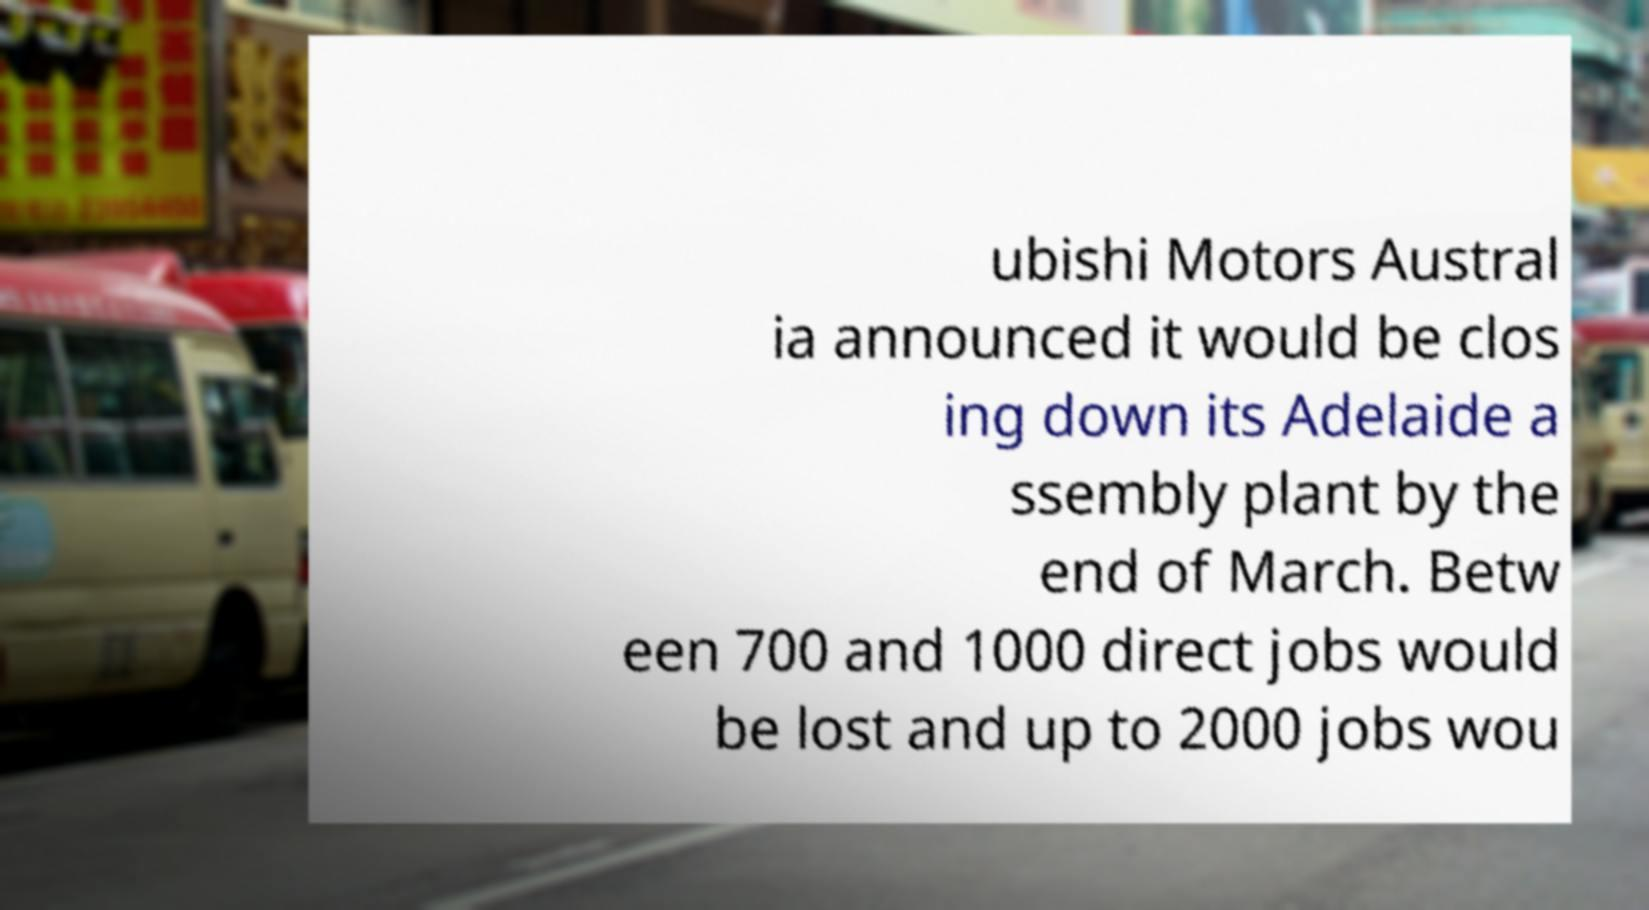For documentation purposes, I need the text within this image transcribed. Could you provide that? ubishi Motors Austral ia announced it would be clos ing down its Adelaide a ssembly plant by the end of March. Betw een 700 and 1000 direct jobs would be lost and up to 2000 jobs wou 